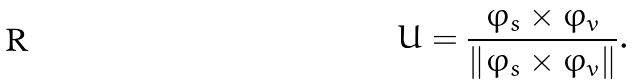Convert formula to latex. <formula><loc_0><loc_0><loc_500><loc_500>U = \frac { \varphi _ { s } \times \varphi _ { v } } { \left \| \varphi _ { s } \times \varphi _ { v } \right \| } .</formula> 